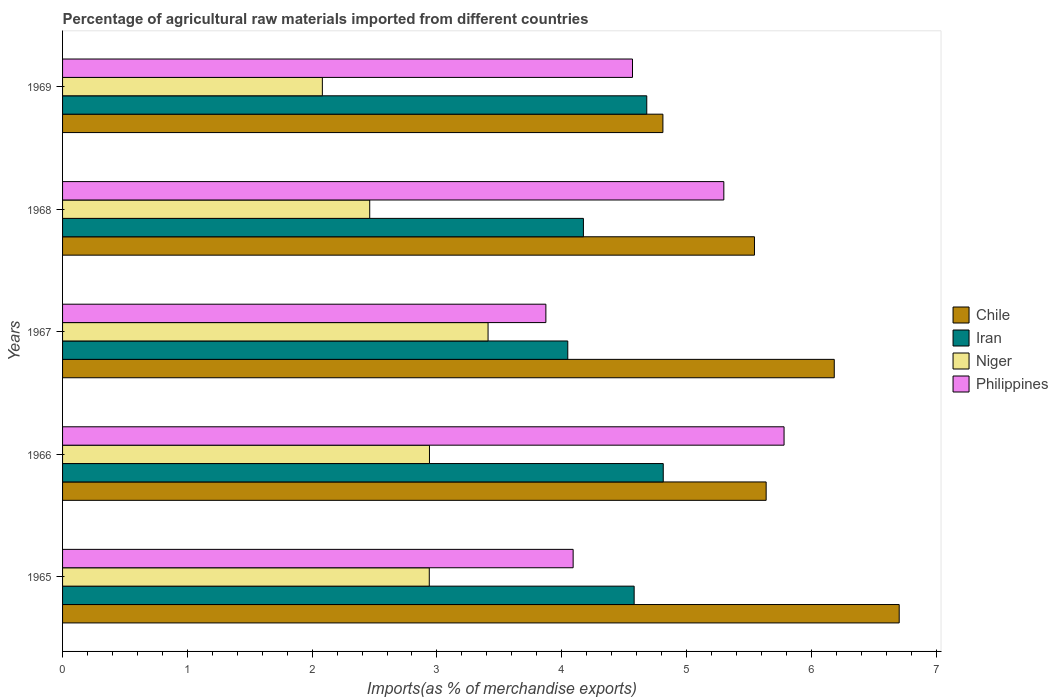How many groups of bars are there?
Provide a short and direct response. 5. Are the number of bars per tick equal to the number of legend labels?
Ensure brevity in your answer.  Yes. Are the number of bars on each tick of the Y-axis equal?
Provide a short and direct response. Yes. How many bars are there on the 5th tick from the bottom?
Your answer should be compact. 4. What is the label of the 5th group of bars from the top?
Keep it short and to the point. 1965. What is the percentage of imports to different countries in Niger in 1965?
Provide a short and direct response. 2.94. Across all years, what is the maximum percentage of imports to different countries in Philippines?
Your answer should be very brief. 5.78. Across all years, what is the minimum percentage of imports to different countries in Chile?
Make the answer very short. 4.81. In which year was the percentage of imports to different countries in Iran maximum?
Offer a terse response. 1966. In which year was the percentage of imports to different countries in Philippines minimum?
Offer a terse response. 1967. What is the total percentage of imports to different countries in Iran in the graph?
Make the answer very short. 22.3. What is the difference between the percentage of imports to different countries in Iran in 1966 and that in 1969?
Keep it short and to the point. 0.13. What is the difference between the percentage of imports to different countries in Chile in 1969 and the percentage of imports to different countries in Philippines in 1968?
Give a very brief answer. -0.49. What is the average percentage of imports to different countries in Chile per year?
Ensure brevity in your answer.  5.78. In the year 1967, what is the difference between the percentage of imports to different countries in Niger and percentage of imports to different countries in Philippines?
Provide a short and direct response. -0.46. What is the ratio of the percentage of imports to different countries in Niger in 1965 to that in 1968?
Your answer should be very brief. 1.19. Is the difference between the percentage of imports to different countries in Niger in 1966 and 1967 greater than the difference between the percentage of imports to different countries in Philippines in 1966 and 1967?
Offer a very short reply. No. What is the difference between the highest and the second highest percentage of imports to different countries in Iran?
Offer a terse response. 0.13. What is the difference between the highest and the lowest percentage of imports to different countries in Chile?
Your response must be concise. 1.89. In how many years, is the percentage of imports to different countries in Philippines greater than the average percentage of imports to different countries in Philippines taken over all years?
Your response must be concise. 2. Is the sum of the percentage of imports to different countries in Iran in 1967 and 1969 greater than the maximum percentage of imports to different countries in Philippines across all years?
Your response must be concise. Yes. Is it the case that in every year, the sum of the percentage of imports to different countries in Iran and percentage of imports to different countries in Niger is greater than the sum of percentage of imports to different countries in Chile and percentage of imports to different countries in Philippines?
Give a very brief answer. No. What does the 2nd bar from the top in 1967 represents?
Give a very brief answer. Niger. What does the 4th bar from the bottom in 1969 represents?
Offer a very short reply. Philippines. Is it the case that in every year, the sum of the percentage of imports to different countries in Philippines and percentage of imports to different countries in Iran is greater than the percentage of imports to different countries in Chile?
Make the answer very short. Yes. How many bars are there?
Your answer should be compact. 20. Are all the bars in the graph horizontal?
Provide a short and direct response. Yes. How many years are there in the graph?
Ensure brevity in your answer.  5. Are the values on the major ticks of X-axis written in scientific E-notation?
Ensure brevity in your answer.  No. Does the graph contain grids?
Provide a succinct answer. No. Where does the legend appear in the graph?
Offer a terse response. Center right. How many legend labels are there?
Make the answer very short. 4. How are the legend labels stacked?
Provide a short and direct response. Vertical. What is the title of the graph?
Your answer should be compact. Percentage of agricultural raw materials imported from different countries. Does "Iran" appear as one of the legend labels in the graph?
Ensure brevity in your answer.  Yes. What is the label or title of the X-axis?
Your response must be concise. Imports(as % of merchandise exports). What is the label or title of the Y-axis?
Your response must be concise. Years. What is the Imports(as % of merchandise exports) in Chile in 1965?
Your answer should be very brief. 6.7. What is the Imports(as % of merchandise exports) of Iran in 1965?
Provide a succinct answer. 4.58. What is the Imports(as % of merchandise exports) of Niger in 1965?
Your response must be concise. 2.94. What is the Imports(as % of merchandise exports) in Philippines in 1965?
Give a very brief answer. 4.09. What is the Imports(as % of merchandise exports) of Chile in 1966?
Your response must be concise. 5.64. What is the Imports(as % of merchandise exports) of Iran in 1966?
Make the answer very short. 4.81. What is the Imports(as % of merchandise exports) of Niger in 1966?
Keep it short and to the point. 2.94. What is the Imports(as % of merchandise exports) of Philippines in 1966?
Provide a short and direct response. 5.78. What is the Imports(as % of merchandise exports) of Chile in 1967?
Your answer should be compact. 6.18. What is the Imports(as % of merchandise exports) of Iran in 1967?
Provide a succinct answer. 4.05. What is the Imports(as % of merchandise exports) of Niger in 1967?
Give a very brief answer. 3.41. What is the Imports(as % of merchandise exports) of Philippines in 1967?
Offer a very short reply. 3.87. What is the Imports(as % of merchandise exports) of Chile in 1968?
Provide a short and direct response. 5.54. What is the Imports(as % of merchandise exports) of Iran in 1968?
Your response must be concise. 4.17. What is the Imports(as % of merchandise exports) of Niger in 1968?
Your response must be concise. 2.46. What is the Imports(as % of merchandise exports) of Philippines in 1968?
Your answer should be very brief. 5.3. What is the Imports(as % of merchandise exports) of Chile in 1969?
Provide a short and direct response. 4.81. What is the Imports(as % of merchandise exports) of Iran in 1969?
Make the answer very short. 4.68. What is the Imports(as % of merchandise exports) of Niger in 1969?
Your answer should be compact. 2.08. What is the Imports(as % of merchandise exports) of Philippines in 1969?
Ensure brevity in your answer.  4.57. Across all years, what is the maximum Imports(as % of merchandise exports) of Chile?
Offer a terse response. 6.7. Across all years, what is the maximum Imports(as % of merchandise exports) of Iran?
Your answer should be compact. 4.81. Across all years, what is the maximum Imports(as % of merchandise exports) in Niger?
Keep it short and to the point. 3.41. Across all years, what is the maximum Imports(as % of merchandise exports) in Philippines?
Make the answer very short. 5.78. Across all years, what is the minimum Imports(as % of merchandise exports) in Chile?
Offer a terse response. 4.81. Across all years, what is the minimum Imports(as % of merchandise exports) in Iran?
Your answer should be compact. 4.05. Across all years, what is the minimum Imports(as % of merchandise exports) in Niger?
Your answer should be very brief. 2.08. Across all years, what is the minimum Imports(as % of merchandise exports) of Philippines?
Ensure brevity in your answer.  3.87. What is the total Imports(as % of merchandise exports) of Chile in the graph?
Provide a short and direct response. 28.88. What is the total Imports(as % of merchandise exports) of Iran in the graph?
Your answer should be very brief. 22.3. What is the total Imports(as % of merchandise exports) of Niger in the graph?
Your answer should be very brief. 13.83. What is the total Imports(as % of merchandise exports) of Philippines in the graph?
Make the answer very short. 23.61. What is the difference between the Imports(as % of merchandise exports) in Chile in 1965 and that in 1966?
Provide a succinct answer. 1.07. What is the difference between the Imports(as % of merchandise exports) of Iran in 1965 and that in 1966?
Provide a succinct answer. -0.23. What is the difference between the Imports(as % of merchandise exports) of Niger in 1965 and that in 1966?
Ensure brevity in your answer.  -0. What is the difference between the Imports(as % of merchandise exports) in Philippines in 1965 and that in 1966?
Your answer should be compact. -1.69. What is the difference between the Imports(as % of merchandise exports) of Chile in 1965 and that in 1967?
Your answer should be very brief. 0.52. What is the difference between the Imports(as % of merchandise exports) in Iran in 1965 and that in 1967?
Provide a short and direct response. 0.53. What is the difference between the Imports(as % of merchandise exports) of Niger in 1965 and that in 1967?
Ensure brevity in your answer.  -0.47. What is the difference between the Imports(as % of merchandise exports) of Philippines in 1965 and that in 1967?
Keep it short and to the point. 0.22. What is the difference between the Imports(as % of merchandise exports) of Chile in 1965 and that in 1968?
Offer a very short reply. 1.16. What is the difference between the Imports(as % of merchandise exports) in Iran in 1965 and that in 1968?
Give a very brief answer. 0.41. What is the difference between the Imports(as % of merchandise exports) of Niger in 1965 and that in 1968?
Give a very brief answer. 0.48. What is the difference between the Imports(as % of merchandise exports) of Philippines in 1965 and that in 1968?
Make the answer very short. -1.21. What is the difference between the Imports(as % of merchandise exports) of Chile in 1965 and that in 1969?
Give a very brief answer. 1.89. What is the difference between the Imports(as % of merchandise exports) of Iran in 1965 and that in 1969?
Make the answer very short. -0.1. What is the difference between the Imports(as % of merchandise exports) in Niger in 1965 and that in 1969?
Your answer should be compact. 0.86. What is the difference between the Imports(as % of merchandise exports) in Philippines in 1965 and that in 1969?
Provide a succinct answer. -0.48. What is the difference between the Imports(as % of merchandise exports) of Chile in 1966 and that in 1967?
Your answer should be very brief. -0.55. What is the difference between the Imports(as % of merchandise exports) in Iran in 1966 and that in 1967?
Make the answer very short. 0.77. What is the difference between the Imports(as % of merchandise exports) of Niger in 1966 and that in 1967?
Offer a terse response. -0.47. What is the difference between the Imports(as % of merchandise exports) in Philippines in 1966 and that in 1967?
Your answer should be compact. 1.91. What is the difference between the Imports(as % of merchandise exports) in Chile in 1966 and that in 1968?
Ensure brevity in your answer.  0.09. What is the difference between the Imports(as % of merchandise exports) of Iran in 1966 and that in 1968?
Give a very brief answer. 0.64. What is the difference between the Imports(as % of merchandise exports) in Niger in 1966 and that in 1968?
Make the answer very short. 0.48. What is the difference between the Imports(as % of merchandise exports) in Philippines in 1966 and that in 1968?
Keep it short and to the point. 0.48. What is the difference between the Imports(as % of merchandise exports) of Chile in 1966 and that in 1969?
Your response must be concise. 0.83. What is the difference between the Imports(as % of merchandise exports) in Iran in 1966 and that in 1969?
Keep it short and to the point. 0.13. What is the difference between the Imports(as % of merchandise exports) of Niger in 1966 and that in 1969?
Offer a terse response. 0.86. What is the difference between the Imports(as % of merchandise exports) of Philippines in 1966 and that in 1969?
Your response must be concise. 1.21. What is the difference between the Imports(as % of merchandise exports) in Chile in 1967 and that in 1968?
Provide a short and direct response. 0.64. What is the difference between the Imports(as % of merchandise exports) in Iran in 1967 and that in 1968?
Your answer should be compact. -0.13. What is the difference between the Imports(as % of merchandise exports) in Niger in 1967 and that in 1968?
Make the answer very short. 0.95. What is the difference between the Imports(as % of merchandise exports) in Philippines in 1967 and that in 1968?
Keep it short and to the point. -1.43. What is the difference between the Imports(as % of merchandise exports) of Chile in 1967 and that in 1969?
Your answer should be compact. 1.37. What is the difference between the Imports(as % of merchandise exports) of Iran in 1967 and that in 1969?
Your answer should be very brief. -0.63. What is the difference between the Imports(as % of merchandise exports) of Niger in 1967 and that in 1969?
Make the answer very short. 1.33. What is the difference between the Imports(as % of merchandise exports) in Philippines in 1967 and that in 1969?
Make the answer very short. -0.69. What is the difference between the Imports(as % of merchandise exports) in Chile in 1968 and that in 1969?
Offer a very short reply. 0.73. What is the difference between the Imports(as % of merchandise exports) in Iran in 1968 and that in 1969?
Make the answer very short. -0.51. What is the difference between the Imports(as % of merchandise exports) in Niger in 1968 and that in 1969?
Make the answer very short. 0.38. What is the difference between the Imports(as % of merchandise exports) of Philippines in 1968 and that in 1969?
Offer a terse response. 0.73. What is the difference between the Imports(as % of merchandise exports) in Chile in 1965 and the Imports(as % of merchandise exports) in Iran in 1966?
Give a very brief answer. 1.89. What is the difference between the Imports(as % of merchandise exports) in Chile in 1965 and the Imports(as % of merchandise exports) in Niger in 1966?
Your answer should be compact. 3.76. What is the difference between the Imports(as % of merchandise exports) of Chile in 1965 and the Imports(as % of merchandise exports) of Philippines in 1966?
Offer a terse response. 0.92. What is the difference between the Imports(as % of merchandise exports) in Iran in 1965 and the Imports(as % of merchandise exports) in Niger in 1966?
Your answer should be compact. 1.64. What is the difference between the Imports(as % of merchandise exports) in Iran in 1965 and the Imports(as % of merchandise exports) in Philippines in 1966?
Your answer should be very brief. -1.2. What is the difference between the Imports(as % of merchandise exports) in Niger in 1965 and the Imports(as % of merchandise exports) in Philippines in 1966?
Ensure brevity in your answer.  -2.84. What is the difference between the Imports(as % of merchandise exports) of Chile in 1965 and the Imports(as % of merchandise exports) of Iran in 1967?
Ensure brevity in your answer.  2.66. What is the difference between the Imports(as % of merchandise exports) in Chile in 1965 and the Imports(as % of merchandise exports) in Niger in 1967?
Your response must be concise. 3.29. What is the difference between the Imports(as % of merchandise exports) in Chile in 1965 and the Imports(as % of merchandise exports) in Philippines in 1967?
Your answer should be very brief. 2.83. What is the difference between the Imports(as % of merchandise exports) of Iran in 1965 and the Imports(as % of merchandise exports) of Niger in 1967?
Give a very brief answer. 1.17. What is the difference between the Imports(as % of merchandise exports) of Iran in 1965 and the Imports(as % of merchandise exports) of Philippines in 1967?
Provide a short and direct response. 0.71. What is the difference between the Imports(as % of merchandise exports) in Niger in 1965 and the Imports(as % of merchandise exports) in Philippines in 1967?
Offer a terse response. -0.93. What is the difference between the Imports(as % of merchandise exports) of Chile in 1965 and the Imports(as % of merchandise exports) of Iran in 1968?
Keep it short and to the point. 2.53. What is the difference between the Imports(as % of merchandise exports) of Chile in 1965 and the Imports(as % of merchandise exports) of Niger in 1968?
Your answer should be compact. 4.24. What is the difference between the Imports(as % of merchandise exports) of Chile in 1965 and the Imports(as % of merchandise exports) of Philippines in 1968?
Provide a short and direct response. 1.41. What is the difference between the Imports(as % of merchandise exports) of Iran in 1965 and the Imports(as % of merchandise exports) of Niger in 1968?
Give a very brief answer. 2.12. What is the difference between the Imports(as % of merchandise exports) in Iran in 1965 and the Imports(as % of merchandise exports) in Philippines in 1968?
Offer a very short reply. -0.72. What is the difference between the Imports(as % of merchandise exports) of Niger in 1965 and the Imports(as % of merchandise exports) of Philippines in 1968?
Provide a short and direct response. -2.36. What is the difference between the Imports(as % of merchandise exports) of Chile in 1965 and the Imports(as % of merchandise exports) of Iran in 1969?
Provide a succinct answer. 2.02. What is the difference between the Imports(as % of merchandise exports) of Chile in 1965 and the Imports(as % of merchandise exports) of Niger in 1969?
Make the answer very short. 4.62. What is the difference between the Imports(as % of merchandise exports) of Chile in 1965 and the Imports(as % of merchandise exports) of Philippines in 1969?
Offer a very short reply. 2.14. What is the difference between the Imports(as % of merchandise exports) in Iran in 1965 and the Imports(as % of merchandise exports) in Niger in 1969?
Ensure brevity in your answer.  2.5. What is the difference between the Imports(as % of merchandise exports) of Iran in 1965 and the Imports(as % of merchandise exports) of Philippines in 1969?
Provide a short and direct response. 0.01. What is the difference between the Imports(as % of merchandise exports) of Niger in 1965 and the Imports(as % of merchandise exports) of Philippines in 1969?
Make the answer very short. -1.63. What is the difference between the Imports(as % of merchandise exports) in Chile in 1966 and the Imports(as % of merchandise exports) in Iran in 1967?
Your answer should be compact. 1.59. What is the difference between the Imports(as % of merchandise exports) of Chile in 1966 and the Imports(as % of merchandise exports) of Niger in 1967?
Your response must be concise. 2.23. What is the difference between the Imports(as % of merchandise exports) of Chile in 1966 and the Imports(as % of merchandise exports) of Philippines in 1967?
Offer a terse response. 1.77. What is the difference between the Imports(as % of merchandise exports) of Iran in 1966 and the Imports(as % of merchandise exports) of Niger in 1967?
Offer a terse response. 1.4. What is the difference between the Imports(as % of merchandise exports) of Iran in 1966 and the Imports(as % of merchandise exports) of Philippines in 1967?
Your answer should be very brief. 0.94. What is the difference between the Imports(as % of merchandise exports) of Niger in 1966 and the Imports(as % of merchandise exports) of Philippines in 1967?
Keep it short and to the point. -0.93. What is the difference between the Imports(as % of merchandise exports) of Chile in 1966 and the Imports(as % of merchandise exports) of Iran in 1968?
Give a very brief answer. 1.46. What is the difference between the Imports(as % of merchandise exports) of Chile in 1966 and the Imports(as % of merchandise exports) of Niger in 1968?
Ensure brevity in your answer.  3.18. What is the difference between the Imports(as % of merchandise exports) in Chile in 1966 and the Imports(as % of merchandise exports) in Philippines in 1968?
Offer a terse response. 0.34. What is the difference between the Imports(as % of merchandise exports) of Iran in 1966 and the Imports(as % of merchandise exports) of Niger in 1968?
Keep it short and to the point. 2.35. What is the difference between the Imports(as % of merchandise exports) of Iran in 1966 and the Imports(as % of merchandise exports) of Philippines in 1968?
Your response must be concise. -0.49. What is the difference between the Imports(as % of merchandise exports) of Niger in 1966 and the Imports(as % of merchandise exports) of Philippines in 1968?
Provide a short and direct response. -2.36. What is the difference between the Imports(as % of merchandise exports) of Chile in 1966 and the Imports(as % of merchandise exports) of Iran in 1969?
Your response must be concise. 0.96. What is the difference between the Imports(as % of merchandise exports) of Chile in 1966 and the Imports(as % of merchandise exports) of Niger in 1969?
Offer a terse response. 3.56. What is the difference between the Imports(as % of merchandise exports) of Chile in 1966 and the Imports(as % of merchandise exports) of Philippines in 1969?
Give a very brief answer. 1.07. What is the difference between the Imports(as % of merchandise exports) in Iran in 1966 and the Imports(as % of merchandise exports) in Niger in 1969?
Offer a terse response. 2.73. What is the difference between the Imports(as % of merchandise exports) of Iran in 1966 and the Imports(as % of merchandise exports) of Philippines in 1969?
Offer a very short reply. 0.25. What is the difference between the Imports(as % of merchandise exports) of Niger in 1966 and the Imports(as % of merchandise exports) of Philippines in 1969?
Your answer should be very brief. -1.63. What is the difference between the Imports(as % of merchandise exports) in Chile in 1967 and the Imports(as % of merchandise exports) in Iran in 1968?
Provide a short and direct response. 2.01. What is the difference between the Imports(as % of merchandise exports) of Chile in 1967 and the Imports(as % of merchandise exports) of Niger in 1968?
Your answer should be compact. 3.72. What is the difference between the Imports(as % of merchandise exports) of Chile in 1967 and the Imports(as % of merchandise exports) of Philippines in 1968?
Ensure brevity in your answer.  0.89. What is the difference between the Imports(as % of merchandise exports) in Iran in 1967 and the Imports(as % of merchandise exports) in Niger in 1968?
Provide a short and direct response. 1.59. What is the difference between the Imports(as % of merchandise exports) in Iran in 1967 and the Imports(as % of merchandise exports) in Philippines in 1968?
Ensure brevity in your answer.  -1.25. What is the difference between the Imports(as % of merchandise exports) in Niger in 1967 and the Imports(as % of merchandise exports) in Philippines in 1968?
Keep it short and to the point. -1.89. What is the difference between the Imports(as % of merchandise exports) of Chile in 1967 and the Imports(as % of merchandise exports) of Iran in 1969?
Provide a succinct answer. 1.5. What is the difference between the Imports(as % of merchandise exports) in Chile in 1967 and the Imports(as % of merchandise exports) in Niger in 1969?
Provide a short and direct response. 4.1. What is the difference between the Imports(as % of merchandise exports) in Chile in 1967 and the Imports(as % of merchandise exports) in Philippines in 1969?
Give a very brief answer. 1.62. What is the difference between the Imports(as % of merchandise exports) in Iran in 1967 and the Imports(as % of merchandise exports) in Niger in 1969?
Your response must be concise. 1.97. What is the difference between the Imports(as % of merchandise exports) of Iran in 1967 and the Imports(as % of merchandise exports) of Philippines in 1969?
Provide a succinct answer. -0.52. What is the difference between the Imports(as % of merchandise exports) in Niger in 1967 and the Imports(as % of merchandise exports) in Philippines in 1969?
Give a very brief answer. -1.16. What is the difference between the Imports(as % of merchandise exports) in Chile in 1968 and the Imports(as % of merchandise exports) in Iran in 1969?
Give a very brief answer. 0.86. What is the difference between the Imports(as % of merchandise exports) of Chile in 1968 and the Imports(as % of merchandise exports) of Niger in 1969?
Make the answer very short. 3.46. What is the difference between the Imports(as % of merchandise exports) of Chile in 1968 and the Imports(as % of merchandise exports) of Philippines in 1969?
Provide a short and direct response. 0.98. What is the difference between the Imports(as % of merchandise exports) in Iran in 1968 and the Imports(as % of merchandise exports) in Niger in 1969?
Keep it short and to the point. 2.09. What is the difference between the Imports(as % of merchandise exports) in Iran in 1968 and the Imports(as % of merchandise exports) in Philippines in 1969?
Your answer should be compact. -0.39. What is the difference between the Imports(as % of merchandise exports) in Niger in 1968 and the Imports(as % of merchandise exports) in Philippines in 1969?
Offer a very short reply. -2.11. What is the average Imports(as % of merchandise exports) in Chile per year?
Your answer should be compact. 5.78. What is the average Imports(as % of merchandise exports) in Iran per year?
Offer a terse response. 4.46. What is the average Imports(as % of merchandise exports) in Niger per year?
Offer a very short reply. 2.77. What is the average Imports(as % of merchandise exports) in Philippines per year?
Your answer should be very brief. 4.72. In the year 1965, what is the difference between the Imports(as % of merchandise exports) in Chile and Imports(as % of merchandise exports) in Iran?
Your answer should be very brief. 2.12. In the year 1965, what is the difference between the Imports(as % of merchandise exports) of Chile and Imports(as % of merchandise exports) of Niger?
Make the answer very short. 3.77. In the year 1965, what is the difference between the Imports(as % of merchandise exports) of Chile and Imports(as % of merchandise exports) of Philippines?
Give a very brief answer. 2.61. In the year 1965, what is the difference between the Imports(as % of merchandise exports) of Iran and Imports(as % of merchandise exports) of Niger?
Offer a terse response. 1.64. In the year 1965, what is the difference between the Imports(as % of merchandise exports) in Iran and Imports(as % of merchandise exports) in Philippines?
Ensure brevity in your answer.  0.49. In the year 1965, what is the difference between the Imports(as % of merchandise exports) of Niger and Imports(as % of merchandise exports) of Philippines?
Make the answer very short. -1.15. In the year 1966, what is the difference between the Imports(as % of merchandise exports) of Chile and Imports(as % of merchandise exports) of Iran?
Provide a short and direct response. 0.82. In the year 1966, what is the difference between the Imports(as % of merchandise exports) in Chile and Imports(as % of merchandise exports) in Niger?
Offer a terse response. 2.7. In the year 1966, what is the difference between the Imports(as % of merchandise exports) in Chile and Imports(as % of merchandise exports) in Philippines?
Make the answer very short. -0.14. In the year 1966, what is the difference between the Imports(as % of merchandise exports) of Iran and Imports(as % of merchandise exports) of Niger?
Make the answer very short. 1.87. In the year 1966, what is the difference between the Imports(as % of merchandise exports) in Iran and Imports(as % of merchandise exports) in Philippines?
Your answer should be very brief. -0.97. In the year 1966, what is the difference between the Imports(as % of merchandise exports) of Niger and Imports(as % of merchandise exports) of Philippines?
Your response must be concise. -2.84. In the year 1967, what is the difference between the Imports(as % of merchandise exports) of Chile and Imports(as % of merchandise exports) of Iran?
Give a very brief answer. 2.14. In the year 1967, what is the difference between the Imports(as % of merchandise exports) of Chile and Imports(as % of merchandise exports) of Niger?
Give a very brief answer. 2.77. In the year 1967, what is the difference between the Imports(as % of merchandise exports) of Chile and Imports(as % of merchandise exports) of Philippines?
Your answer should be very brief. 2.31. In the year 1967, what is the difference between the Imports(as % of merchandise exports) of Iran and Imports(as % of merchandise exports) of Niger?
Your answer should be very brief. 0.64. In the year 1967, what is the difference between the Imports(as % of merchandise exports) of Iran and Imports(as % of merchandise exports) of Philippines?
Ensure brevity in your answer.  0.18. In the year 1967, what is the difference between the Imports(as % of merchandise exports) in Niger and Imports(as % of merchandise exports) in Philippines?
Your answer should be very brief. -0.46. In the year 1968, what is the difference between the Imports(as % of merchandise exports) of Chile and Imports(as % of merchandise exports) of Iran?
Ensure brevity in your answer.  1.37. In the year 1968, what is the difference between the Imports(as % of merchandise exports) of Chile and Imports(as % of merchandise exports) of Niger?
Keep it short and to the point. 3.08. In the year 1968, what is the difference between the Imports(as % of merchandise exports) of Chile and Imports(as % of merchandise exports) of Philippines?
Provide a succinct answer. 0.25. In the year 1968, what is the difference between the Imports(as % of merchandise exports) in Iran and Imports(as % of merchandise exports) in Niger?
Keep it short and to the point. 1.71. In the year 1968, what is the difference between the Imports(as % of merchandise exports) of Iran and Imports(as % of merchandise exports) of Philippines?
Give a very brief answer. -1.13. In the year 1968, what is the difference between the Imports(as % of merchandise exports) in Niger and Imports(as % of merchandise exports) in Philippines?
Provide a succinct answer. -2.84. In the year 1969, what is the difference between the Imports(as % of merchandise exports) in Chile and Imports(as % of merchandise exports) in Iran?
Provide a succinct answer. 0.13. In the year 1969, what is the difference between the Imports(as % of merchandise exports) of Chile and Imports(as % of merchandise exports) of Niger?
Keep it short and to the point. 2.73. In the year 1969, what is the difference between the Imports(as % of merchandise exports) of Chile and Imports(as % of merchandise exports) of Philippines?
Offer a very short reply. 0.24. In the year 1969, what is the difference between the Imports(as % of merchandise exports) in Iran and Imports(as % of merchandise exports) in Niger?
Offer a very short reply. 2.6. In the year 1969, what is the difference between the Imports(as % of merchandise exports) in Iran and Imports(as % of merchandise exports) in Philippines?
Provide a short and direct response. 0.11. In the year 1969, what is the difference between the Imports(as % of merchandise exports) of Niger and Imports(as % of merchandise exports) of Philippines?
Provide a short and direct response. -2.49. What is the ratio of the Imports(as % of merchandise exports) of Chile in 1965 to that in 1966?
Keep it short and to the point. 1.19. What is the ratio of the Imports(as % of merchandise exports) of Iran in 1965 to that in 1966?
Your answer should be very brief. 0.95. What is the ratio of the Imports(as % of merchandise exports) in Niger in 1965 to that in 1966?
Provide a short and direct response. 1. What is the ratio of the Imports(as % of merchandise exports) of Philippines in 1965 to that in 1966?
Your answer should be compact. 0.71. What is the ratio of the Imports(as % of merchandise exports) in Chile in 1965 to that in 1967?
Offer a very short reply. 1.08. What is the ratio of the Imports(as % of merchandise exports) in Iran in 1965 to that in 1967?
Offer a terse response. 1.13. What is the ratio of the Imports(as % of merchandise exports) in Niger in 1965 to that in 1967?
Offer a very short reply. 0.86. What is the ratio of the Imports(as % of merchandise exports) in Philippines in 1965 to that in 1967?
Offer a terse response. 1.06. What is the ratio of the Imports(as % of merchandise exports) of Chile in 1965 to that in 1968?
Your response must be concise. 1.21. What is the ratio of the Imports(as % of merchandise exports) of Iran in 1965 to that in 1968?
Offer a terse response. 1.1. What is the ratio of the Imports(as % of merchandise exports) of Niger in 1965 to that in 1968?
Offer a very short reply. 1.19. What is the ratio of the Imports(as % of merchandise exports) in Philippines in 1965 to that in 1968?
Provide a short and direct response. 0.77. What is the ratio of the Imports(as % of merchandise exports) of Chile in 1965 to that in 1969?
Your answer should be compact. 1.39. What is the ratio of the Imports(as % of merchandise exports) of Iran in 1965 to that in 1969?
Provide a short and direct response. 0.98. What is the ratio of the Imports(as % of merchandise exports) of Niger in 1965 to that in 1969?
Your answer should be very brief. 1.41. What is the ratio of the Imports(as % of merchandise exports) of Philippines in 1965 to that in 1969?
Your answer should be compact. 0.9. What is the ratio of the Imports(as % of merchandise exports) of Chile in 1966 to that in 1967?
Offer a very short reply. 0.91. What is the ratio of the Imports(as % of merchandise exports) of Iran in 1966 to that in 1967?
Make the answer very short. 1.19. What is the ratio of the Imports(as % of merchandise exports) in Niger in 1966 to that in 1967?
Provide a short and direct response. 0.86. What is the ratio of the Imports(as % of merchandise exports) of Philippines in 1966 to that in 1967?
Offer a very short reply. 1.49. What is the ratio of the Imports(as % of merchandise exports) of Chile in 1966 to that in 1968?
Your answer should be compact. 1.02. What is the ratio of the Imports(as % of merchandise exports) of Iran in 1966 to that in 1968?
Provide a succinct answer. 1.15. What is the ratio of the Imports(as % of merchandise exports) in Niger in 1966 to that in 1968?
Offer a terse response. 1.19. What is the ratio of the Imports(as % of merchandise exports) of Philippines in 1966 to that in 1968?
Offer a terse response. 1.09. What is the ratio of the Imports(as % of merchandise exports) of Chile in 1966 to that in 1969?
Keep it short and to the point. 1.17. What is the ratio of the Imports(as % of merchandise exports) of Iran in 1966 to that in 1969?
Offer a terse response. 1.03. What is the ratio of the Imports(as % of merchandise exports) of Niger in 1966 to that in 1969?
Keep it short and to the point. 1.41. What is the ratio of the Imports(as % of merchandise exports) of Philippines in 1966 to that in 1969?
Give a very brief answer. 1.27. What is the ratio of the Imports(as % of merchandise exports) of Chile in 1967 to that in 1968?
Provide a short and direct response. 1.12. What is the ratio of the Imports(as % of merchandise exports) of Niger in 1967 to that in 1968?
Give a very brief answer. 1.39. What is the ratio of the Imports(as % of merchandise exports) in Philippines in 1967 to that in 1968?
Give a very brief answer. 0.73. What is the ratio of the Imports(as % of merchandise exports) in Chile in 1967 to that in 1969?
Ensure brevity in your answer.  1.29. What is the ratio of the Imports(as % of merchandise exports) of Iran in 1967 to that in 1969?
Give a very brief answer. 0.86. What is the ratio of the Imports(as % of merchandise exports) in Niger in 1967 to that in 1969?
Your answer should be very brief. 1.64. What is the ratio of the Imports(as % of merchandise exports) in Philippines in 1967 to that in 1969?
Offer a very short reply. 0.85. What is the ratio of the Imports(as % of merchandise exports) in Chile in 1968 to that in 1969?
Ensure brevity in your answer.  1.15. What is the ratio of the Imports(as % of merchandise exports) of Iran in 1968 to that in 1969?
Offer a very short reply. 0.89. What is the ratio of the Imports(as % of merchandise exports) of Niger in 1968 to that in 1969?
Your answer should be very brief. 1.18. What is the ratio of the Imports(as % of merchandise exports) in Philippines in 1968 to that in 1969?
Provide a succinct answer. 1.16. What is the difference between the highest and the second highest Imports(as % of merchandise exports) in Chile?
Your answer should be very brief. 0.52. What is the difference between the highest and the second highest Imports(as % of merchandise exports) of Iran?
Offer a terse response. 0.13. What is the difference between the highest and the second highest Imports(as % of merchandise exports) in Niger?
Provide a succinct answer. 0.47. What is the difference between the highest and the second highest Imports(as % of merchandise exports) in Philippines?
Your response must be concise. 0.48. What is the difference between the highest and the lowest Imports(as % of merchandise exports) in Chile?
Your answer should be compact. 1.89. What is the difference between the highest and the lowest Imports(as % of merchandise exports) in Iran?
Your answer should be very brief. 0.77. What is the difference between the highest and the lowest Imports(as % of merchandise exports) of Niger?
Offer a terse response. 1.33. What is the difference between the highest and the lowest Imports(as % of merchandise exports) in Philippines?
Your response must be concise. 1.91. 